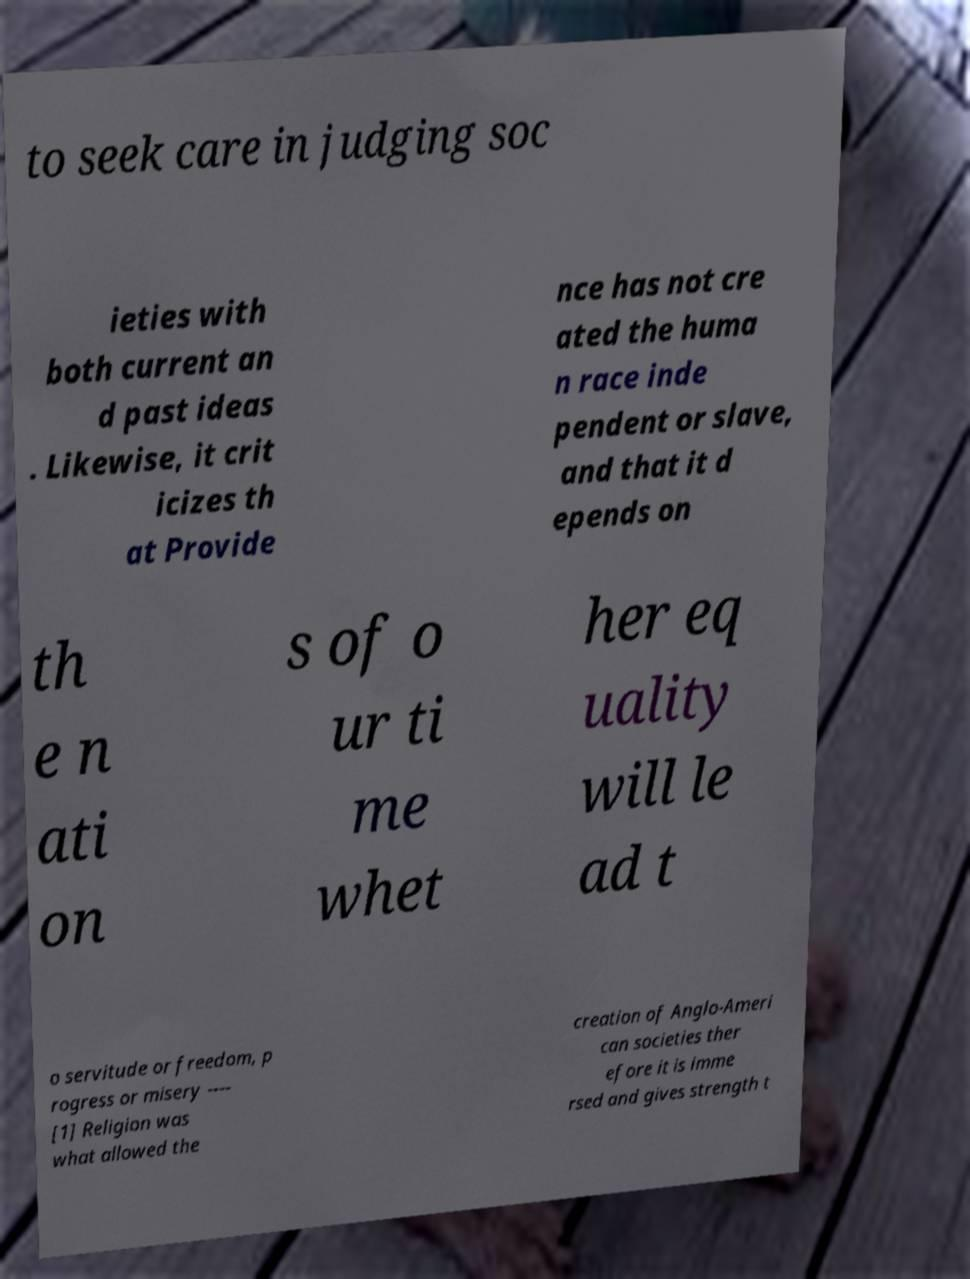Can you accurately transcribe the text from the provided image for me? to seek care in judging soc ieties with both current an d past ideas . Likewise, it crit icizes th at Provide nce has not cre ated the huma n race inde pendent or slave, and that it d epends on th e n ati on s of o ur ti me whet her eq uality will le ad t o servitude or freedom, p rogress or misery ---- [1] Religion was what allowed the creation of Anglo-Ameri can societies ther efore it is imme rsed and gives strength t 